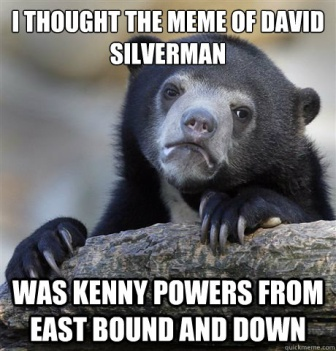Can you describe a humorous scenario involving the bear? Imagine the bear, trying to watch TV in the middle of the forest, using a makeshift satellite dish made of twigs and leaves. It finally manages to get a signal and tunes into 'East Bound and Down,' completely engrossed. Suddenly, it hears a rustle in the forest and quickly changes the channel to a nature documentary, just in time for some human hikers to pass by. The hikers glance at the bear, nod in understanding, and continue their trek, assuming the bear was just learning survival skills from the documentary. 